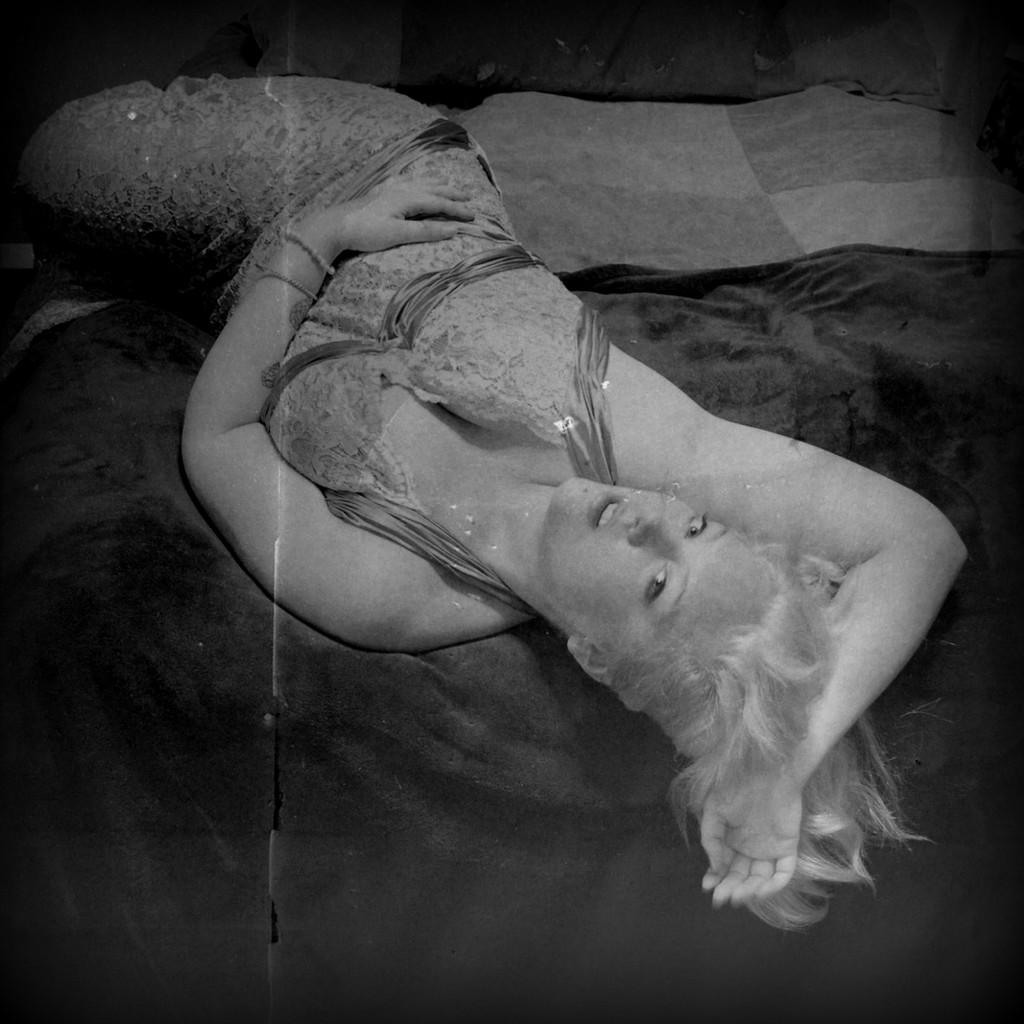Who is present in the image? There is a woman in the image. What is the woman doing in the image? The woman is laying on a bed. Can you describe any specific details about the image? There is a black color cloth in the image. What type of camp can be seen in the background of the image? There is no camp visible in the image; it only features a woman laying on a bed and a black color cloth. 